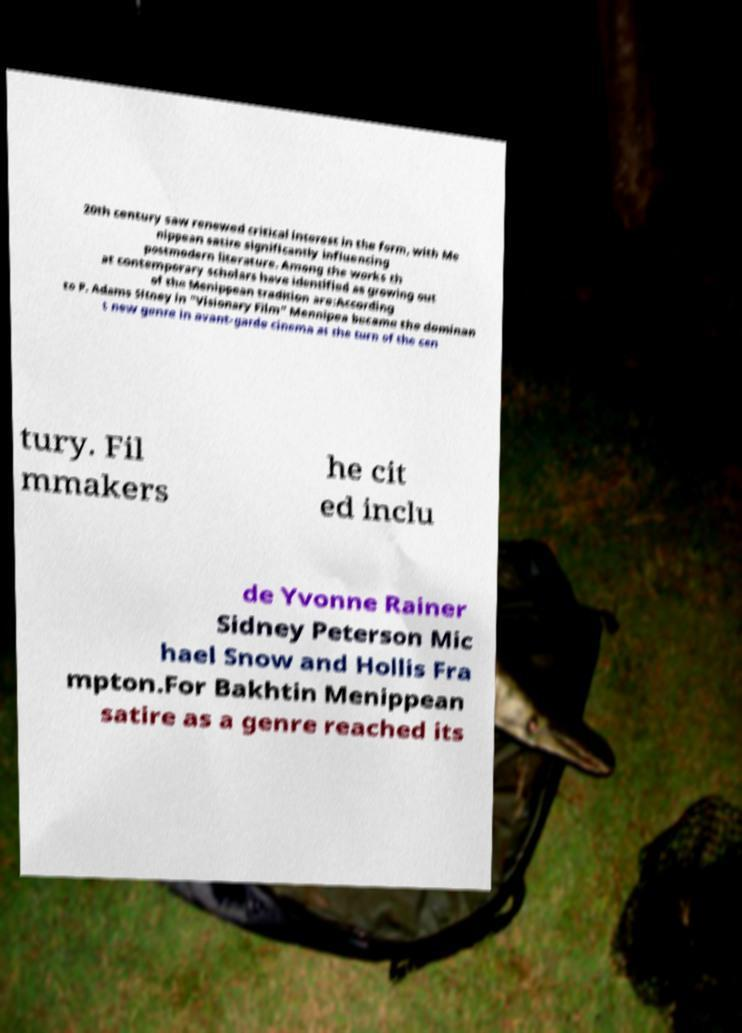Please read and relay the text visible in this image. What does it say? 20th century saw renewed critical interest in the form, with Me nippean satire significantly influencing postmodern literature. Among the works th at contemporary scholars have identified as growing out of the Menippean tradition are:According to P. Adams Sitney in "Visionary Film" Mennipea became the dominan t new genre in avant-garde cinema at the turn of the cen tury. Fil mmakers he cit ed inclu de Yvonne Rainer Sidney Peterson Mic hael Snow and Hollis Fra mpton.For Bakhtin Menippean satire as a genre reached its 